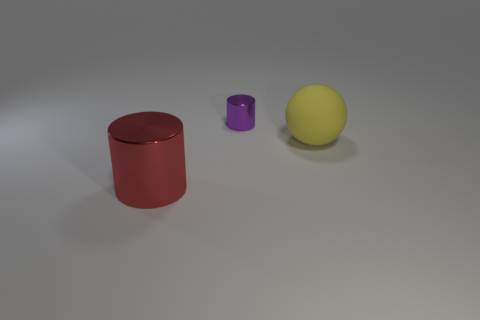Add 2 red metal balls. How many objects exist? 5 Subtract all cylinders. How many objects are left? 1 Add 1 big yellow rubber spheres. How many big yellow rubber spheres exist? 2 Subtract 0 gray blocks. How many objects are left? 3 Subtract all gray balls. Subtract all blue blocks. How many balls are left? 1 Subtract all small shiny cylinders. Subtract all cylinders. How many objects are left? 0 Add 1 large shiny things. How many large shiny things are left? 2 